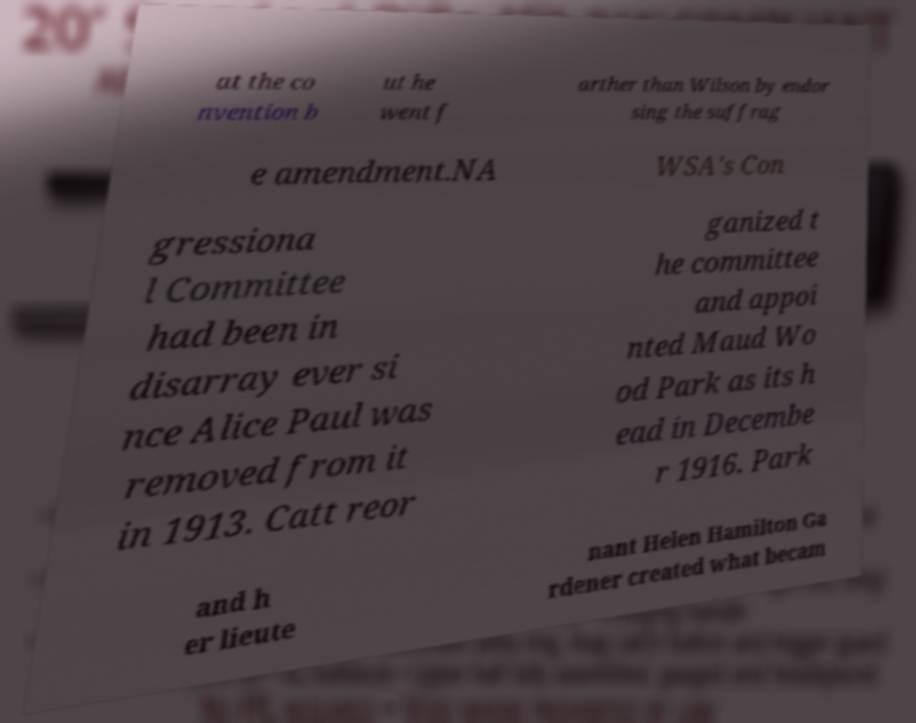Could you extract and type out the text from this image? at the co nvention b ut he went f arther than Wilson by endor sing the suffrag e amendment.NA WSA's Con gressiona l Committee had been in disarray ever si nce Alice Paul was removed from it in 1913. Catt reor ganized t he committee and appoi nted Maud Wo od Park as its h ead in Decembe r 1916. Park and h er lieute nant Helen Hamilton Ga rdener created what becam 